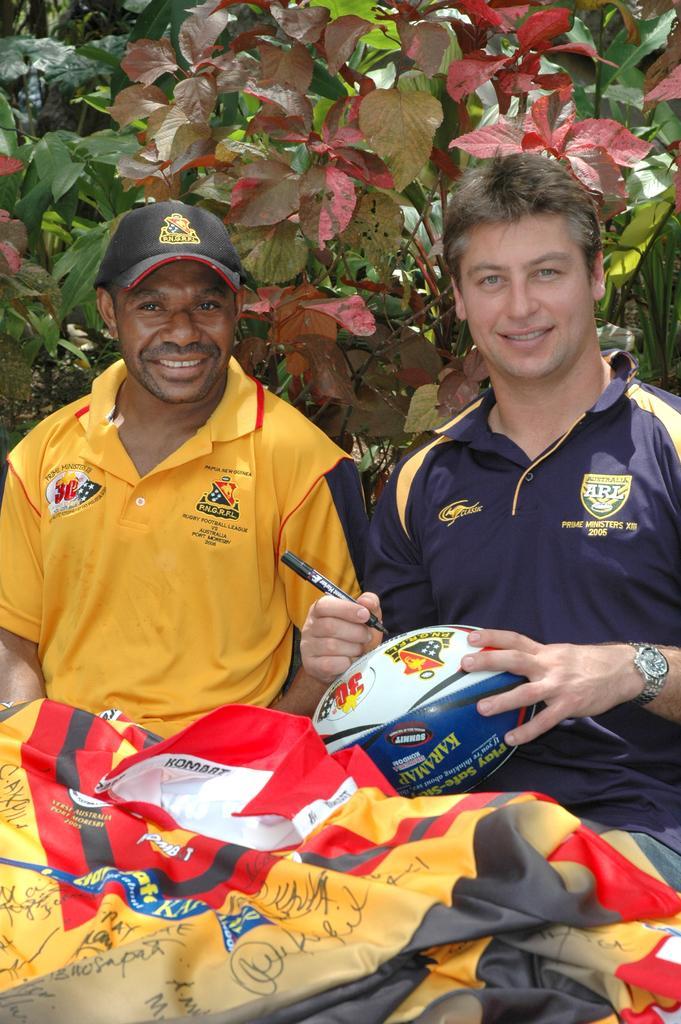Could you give a brief overview of what you see in this image? Here in this picture we can see two men are sitting and they both are smiling. The man with blue t-shirt is catching a ball and signing on it. In front of them there are some t-shirts. At the back of them there are some trees. 